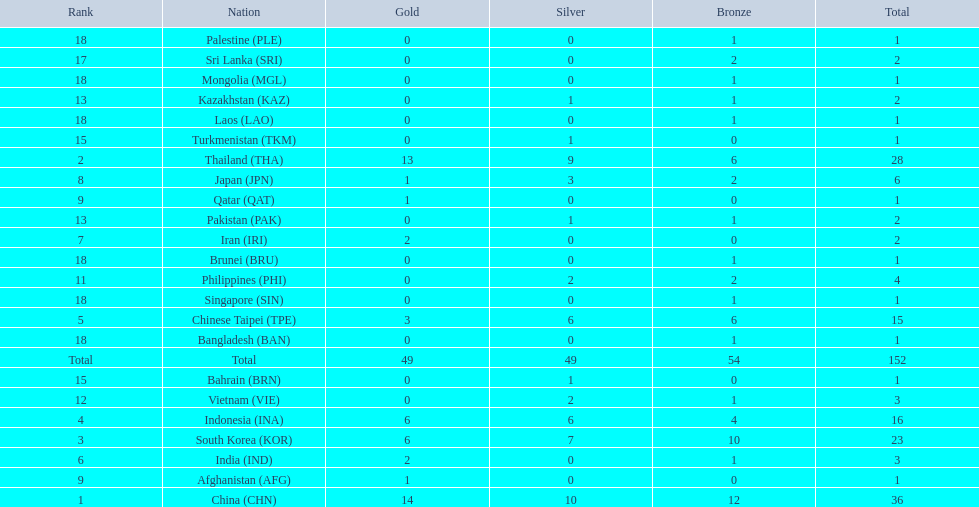How many nations received more than 5 gold medals? 4. 